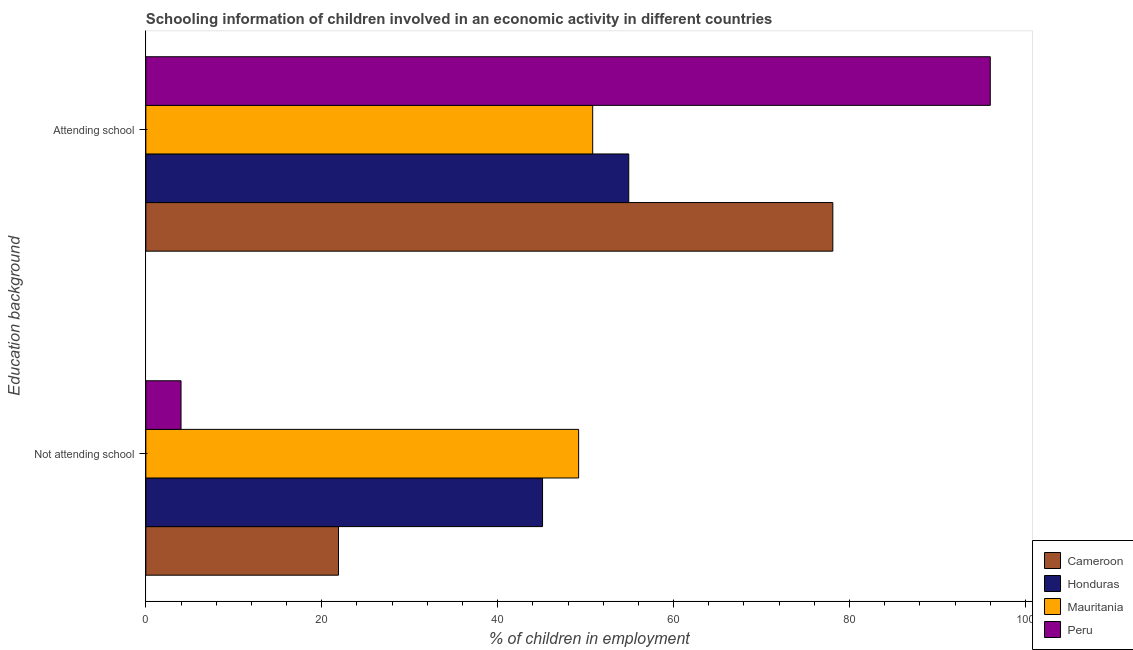How many different coloured bars are there?
Provide a short and direct response. 4. How many groups of bars are there?
Offer a very short reply. 2. Are the number of bars on each tick of the Y-axis equal?
Make the answer very short. Yes. What is the label of the 1st group of bars from the top?
Offer a terse response. Attending school. What is the percentage of employed children who are not attending school in Mauritania?
Offer a very short reply. 49.2. Across all countries, what is the maximum percentage of employed children who are not attending school?
Ensure brevity in your answer.  49.2. Across all countries, what is the minimum percentage of employed children who are attending school?
Offer a very short reply. 50.8. In which country was the percentage of employed children who are not attending school maximum?
Keep it short and to the point. Mauritania. In which country was the percentage of employed children who are attending school minimum?
Give a very brief answer. Mauritania. What is the total percentage of employed children who are attending school in the graph?
Give a very brief answer. 279.8. What is the difference between the percentage of employed children who are not attending school in Cameroon and that in Honduras?
Provide a short and direct response. -23.2. What is the difference between the percentage of employed children who are not attending school in Cameroon and the percentage of employed children who are attending school in Mauritania?
Your answer should be very brief. -28.9. What is the average percentage of employed children who are not attending school per country?
Offer a terse response. 30.05. What is the difference between the percentage of employed children who are not attending school and percentage of employed children who are attending school in Cameroon?
Ensure brevity in your answer.  -56.2. In how many countries, is the percentage of employed children who are attending school greater than 48 %?
Your response must be concise. 4. What is the ratio of the percentage of employed children who are not attending school in Cameroon to that in Honduras?
Ensure brevity in your answer.  0.49. Is the percentage of employed children who are attending school in Mauritania less than that in Peru?
Offer a very short reply. Yes. What does the 4th bar from the top in Attending school represents?
Make the answer very short. Cameroon. What does the 3rd bar from the bottom in Not attending school represents?
Your answer should be compact. Mauritania. How many countries are there in the graph?
Offer a terse response. 4. What is the difference between two consecutive major ticks on the X-axis?
Give a very brief answer. 20. Does the graph contain any zero values?
Keep it short and to the point. No. Where does the legend appear in the graph?
Offer a terse response. Bottom right. How many legend labels are there?
Provide a short and direct response. 4. What is the title of the graph?
Provide a short and direct response. Schooling information of children involved in an economic activity in different countries. Does "Bahamas" appear as one of the legend labels in the graph?
Your response must be concise. No. What is the label or title of the X-axis?
Make the answer very short. % of children in employment. What is the label or title of the Y-axis?
Provide a short and direct response. Education background. What is the % of children in employment in Cameroon in Not attending school?
Provide a succinct answer. 21.9. What is the % of children in employment of Honduras in Not attending school?
Your answer should be very brief. 45.1. What is the % of children in employment of Mauritania in Not attending school?
Offer a very short reply. 49.2. What is the % of children in employment in Peru in Not attending school?
Offer a terse response. 4. What is the % of children in employment of Cameroon in Attending school?
Make the answer very short. 78.1. What is the % of children in employment in Honduras in Attending school?
Make the answer very short. 54.9. What is the % of children in employment of Mauritania in Attending school?
Give a very brief answer. 50.8. What is the % of children in employment of Peru in Attending school?
Provide a succinct answer. 96. Across all Education background, what is the maximum % of children in employment in Cameroon?
Provide a short and direct response. 78.1. Across all Education background, what is the maximum % of children in employment in Honduras?
Offer a very short reply. 54.9. Across all Education background, what is the maximum % of children in employment of Mauritania?
Your response must be concise. 50.8. Across all Education background, what is the maximum % of children in employment in Peru?
Your answer should be compact. 96. Across all Education background, what is the minimum % of children in employment in Cameroon?
Ensure brevity in your answer.  21.9. Across all Education background, what is the minimum % of children in employment in Honduras?
Give a very brief answer. 45.1. Across all Education background, what is the minimum % of children in employment in Mauritania?
Your response must be concise. 49.2. What is the total % of children in employment in Cameroon in the graph?
Ensure brevity in your answer.  100. What is the total % of children in employment in Honduras in the graph?
Provide a short and direct response. 100. What is the total % of children in employment in Mauritania in the graph?
Your response must be concise. 100. What is the total % of children in employment of Peru in the graph?
Offer a very short reply. 100. What is the difference between the % of children in employment in Cameroon in Not attending school and that in Attending school?
Keep it short and to the point. -56.2. What is the difference between the % of children in employment in Honduras in Not attending school and that in Attending school?
Your answer should be compact. -9.8. What is the difference between the % of children in employment in Mauritania in Not attending school and that in Attending school?
Give a very brief answer. -1.6. What is the difference between the % of children in employment in Peru in Not attending school and that in Attending school?
Ensure brevity in your answer.  -92. What is the difference between the % of children in employment in Cameroon in Not attending school and the % of children in employment in Honduras in Attending school?
Offer a terse response. -33. What is the difference between the % of children in employment in Cameroon in Not attending school and the % of children in employment in Mauritania in Attending school?
Your answer should be very brief. -28.9. What is the difference between the % of children in employment in Cameroon in Not attending school and the % of children in employment in Peru in Attending school?
Make the answer very short. -74.1. What is the difference between the % of children in employment in Honduras in Not attending school and the % of children in employment in Mauritania in Attending school?
Provide a short and direct response. -5.7. What is the difference between the % of children in employment of Honduras in Not attending school and the % of children in employment of Peru in Attending school?
Ensure brevity in your answer.  -50.9. What is the difference between the % of children in employment in Mauritania in Not attending school and the % of children in employment in Peru in Attending school?
Your answer should be compact. -46.8. What is the average % of children in employment of Honduras per Education background?
Provide a short and direct response. 50. What is the average % of children in employment of Mauritania per Education background?
Keep it short and to the point. 50. What is the difference between the % of children in employment of Cameroon and % of children in employment of Honduras in Not attending school?
Keep it short and to the point. -23.2. What is the difference between the % of children in employment of Cameroon and % of children in employment of Mauritania in Not attending school?
Provide a short and direct response. -27.3. What is the difference between the % of children in employment of Honduras and % of children in employment of Peru in Not attending school?
Your response must be concise. 41.1. What is the difference between the % of children in employment of Mauritania and % of children in employment of Peru in Not attending school?
Offer a terse response. 45.2. What is the difference between the % of children in employment in Cameroon and % of children in employment in Honduras in Attending school?
Ensure brevity in your answer.  23.2. What is the difference between the % of children in employment of Cameroon and % of children in employment of Mauritania in Attending school?
Keep it short and to the point. 27.3. What is the difference between the % of children in employment of Cameroon and % of children in employment of Peru in Attending school?
Your answer should be compact. -17.9. What is the difference between the % of children in employment in Honduras and % of children in employment in Peru in Attending school?
Your answer should be very brief. -41.1. What is the difference between the % of children in employment in Mauritania and % of children in employment in Peru in Attending school?
Give a very brief answer. -45.2. What is the ratio of the % of children in employment in Cameroon in Not attending school to that in Attending school?
Your response must be concise. 0.28. What is the ratio of the % of children in employment of Honduras in Not attending school to that in Attending school?
Keep it short and to the point. 0.82. What is the ratio of the % of children in employment in Mauritania in Not attending school to that in Attending school?
Offer a terse response. 0.97. What is the ratio of the % of children in employment of Peru in Not attending school to that in Attending school?
Your answer should be very brief. 0.04. What is the difference between the highest and the second highest % of children in employment of Cameroon?
Keep it short and to the point. 56.2. What is the difference between the highest and the second highest % of children in employment of Mauritania?
Your answer should be very brief. 1.6. What is the difference between the highest and the second highest % of children in employment in Peru?
Your response must be concise. 92. What is the difference between the highest and the lowest % of children in employment of Cameroon?
Provide a short and direct response. 56.2. What is the difference between the highest and the lowest % of children in employment of Peru?
Offer a very short reply. 92. 